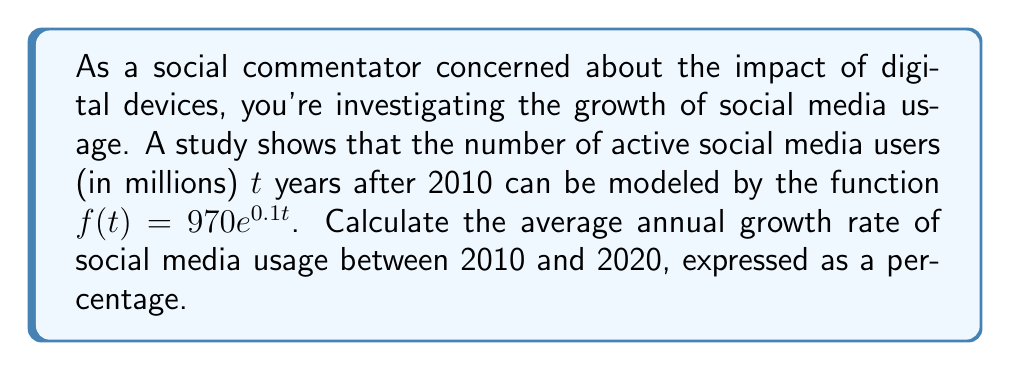Give your solution to this math problem. To solve this problem, we'll follow these steps:

1) First, let's calculate the number of users in 2010 and 2020:

   For 2010: $t = 0$
   $f(0) = 970e^{0.1(0)} = 970$ million users

   For 2020: $t = 10$
   $f(10) = 970e^{0.1(10)} = 970e^1 \approx 2636.65$ million users

2) Now, we need to calculate the average annual growth rate. We can use the compound interest formula:

   $A = P(1+r)^n$

   Where:
   $A$ is the final amount
   $P$ is the initial amount
   $r$ is the annual growth rate
   $n$ is the number of years

3) Plugging in our values:

   $2636.65 = 970(1+r)^{10}$

4) Solve for $r$:

   $\frac{2636.65}{970} = (1+r)^{10}$
   
   $2.71820 = (1+r)^{10}$
   
   $\sqrt[10]{2.71820} = 1+r$
   
   $1.10517 = 1+r$
   
   $r = 0.10517$

5) Convert to a percentage:

   $0.10517 \times 100 = 10.517\%$
Answer: The average annual growth rate of social media usage between 2010 and 2020 is approximately 10.52%. 